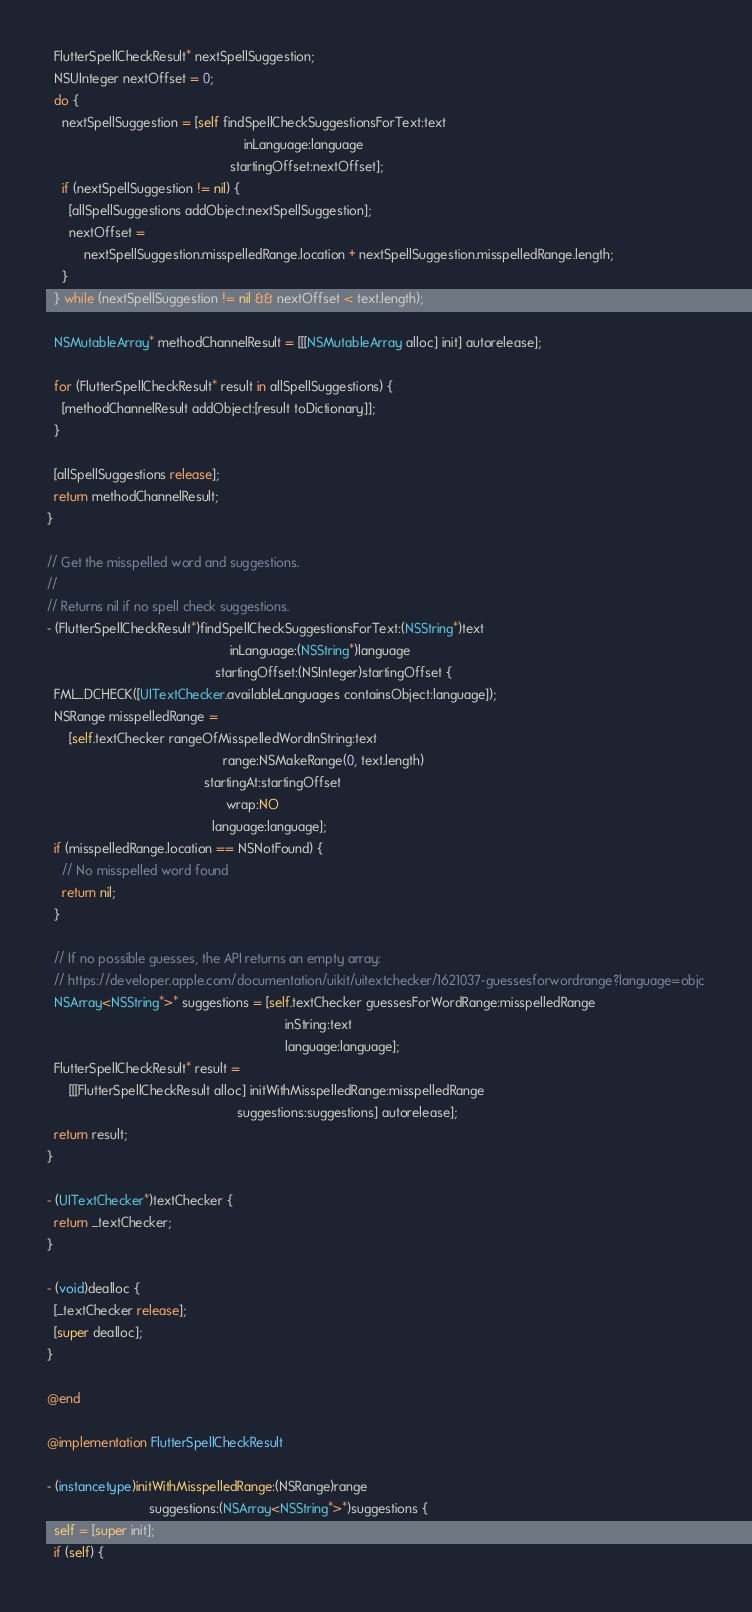<code> <loc_0><loc_0><loc_500><loc_500><_ObjectiveC_>  FlutterSpellCheckResult* nextSpellSuggestion;
  NSUInteger nextOffset = 0;
  do {
    nextSpellSuggestion = [self findSpellCheckSuggestionsForText:text
                                                      inLanguage:language
                                                  startingOffset:nextOffset];
    if (nextSpellSuggestion != nil) {
      [allSpellSuggestions addObject:nextSpellSuggestion];
      nextOffset =
          nextSpellSuggestion.misspelledRange.location + nextSpellSuggestion.misspelledRange.length;
    }
  } while (nextSpellSuggestion != nil && nextOffset < text.length);

  NSMutableArray* methodChannelResult = [[[NSMutableArray alloc] init] autorelease];

  for (FlutterSpellCheckResult* result in allSpellSuggestions) {
    [methodChannelResult addObject:[result toDictionary]];
  }

  [allSpellSuggestions release];
  return methodChannelResult;
}

// Get the misspelled word and suggestions.
//
// Returns nil if no spell check suggestions.
- (FlutterSpellCheckResult*)findSpellCheckSuggestionsForText:(NSString*)text
                                                  inLanguage:(NSString*)language
                                              startingOffset:(NSInteger)startingOffset {
  FML_DCHECK([UITextChecker.availableLanguages containsObject:language]);
  NSRange misspelledRange =
      [self.textChecker rangeOfMisspelledWordInString:text
                                                range:NSMakeRange(0, text.length)
                                           startingAt:startingOffset
                                                 wrap:NO
                                             language:language];
  if (misspelledRange.location == NSNotFound) {
    // No misspelled word found
    return nil;
  }

  // If no possible guesses, the API returns an empty array:
  // https://developer.apple.com/documentation/uikit/uitextchecker/1621037-guessesforwordrange?language=objc
  NSArray<NSString*>* suggestions = [self.textChecker guessesForWordRange:misspelledRange
                                                                 inString:text
                                                                 language:language];
  FlutterSpellCheckResult* result =
      [[[FlutterSpellCheckResult alloc] initWithMisspelledRange:misspelledRange
                                                    suggestions:suggestions] autorelease];
  return result;
}

- (UITextChecker*)textChecker {
  return _textChecker;
}

- (void)dealloc {
  [_textChecker release];
  [super dealloc];
}

@end

@implementation FlutterSpellCheckResult

- (instancetype)initWithMisspelledRange:(NSRange)range
                            suggestions:(NSArray<NSString*>*)suggestions {
  self = [super init];
  if (self) {</code> 